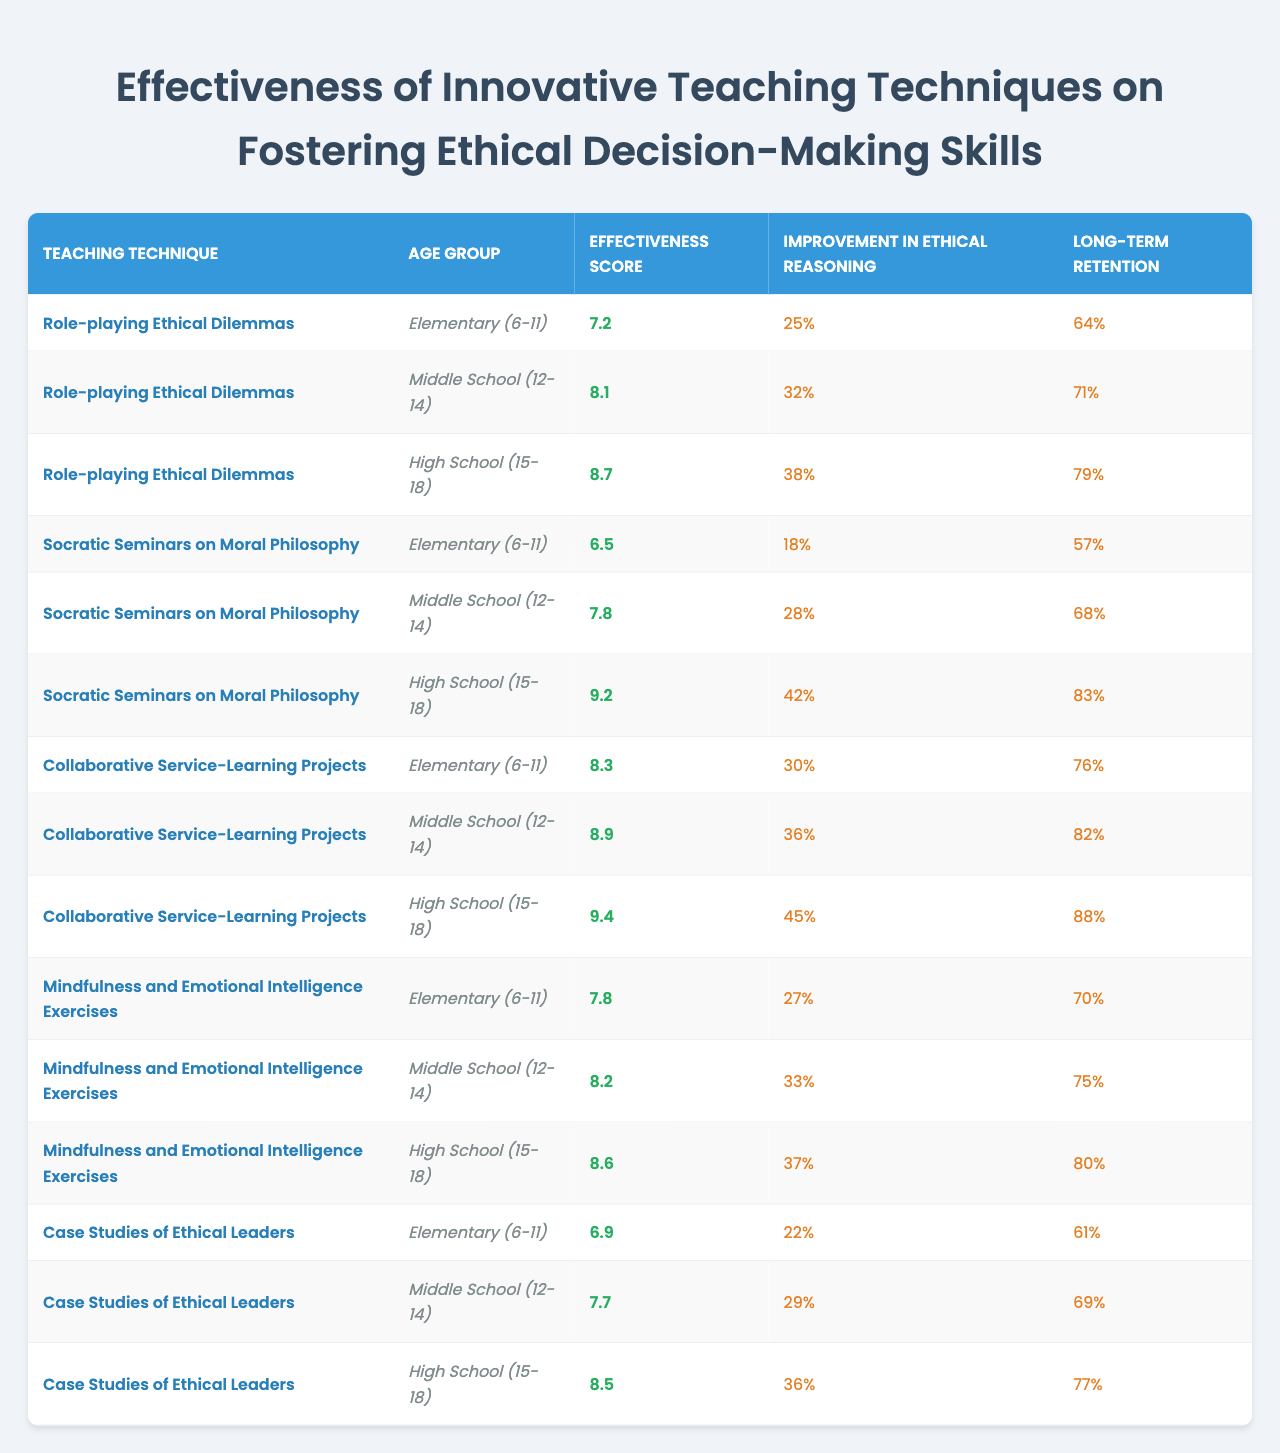What is the effectiveness score for Role-playing Ethical Dilemmas in High School? The table shows that the effectiveness score for the Role-playing Ethical Dilemmas technique in the High School age group is 8.7.
Answer: 8.7 Which technique has the highest effectiveness score for Middle School students? By comparing the effectiveness scores for Middle School students, Collaborative Service-Learning Projects has the highest score at 8.9.
Answer: Collaborative Service-Learning Projects What is the percentage improvement in ethical reasoning for the Elementary age group using Socratic Seminars on Moral Philosophy? The improvement in ethical reasoning for the Elementary age group using Socratic Seminars on Moral Philosophy is 18%, as stated in the table.
Answer: 18% How does the long-term retention of ethical decision-making skills compare between Role-playing Ethical Dilemmas and Mindfulness and Emotional Intelligence Exercises for High School students? The long-term retention for Role-playing Ethical Dilemmas is 79% and for Mindfulness and Emotional Intelligence Exercises it is 80%. Mindfulness and Emotional Intelligence Exercises has a slightly higher retention rate.
Answer: Mindfulness and Emotional Intelligence Exercises What is the average effectiveness score across all techniques for the Middle School age group? The effectiveness scores for Middle School students are 8.1 (Role-playing Ethical Dilemmas), 7.8 (Socratic Seminars), 8.9 (Collaborative Service-Learning), 8.2 (Mindfulness), and 7.7 (Case Studies). Thus, the average is (8.1 + 7.8 + 8.9 + 8.2 + 7.7) / 5 = 8.174.
Answer: 8.174 Is the improvement in ethical reasoning greater for High School students using Collaborative Service-Learning Projects or Role-playing Ethical Dilemmas? Collaborative Service-Learning Projects shows a 45% improvement, while Role-playing Ethical Dilemmas shows a 38% improvement. Therefore, the improvement is greater for Collaborative Service-Learning Projects.
Answer: Yes What percentage improvement does Mindfulness and Emotional Intelligence Exercises show for High School students compared to Elementary students? Mindfulness and Emotional Intelligence Exercises shows a 37% improvement for High School students and 27% for Elementary students. The difference is 37% - 27% = 10%, indicating a 10% greater improvement in High School students.
Answer: 10% Which technique shows the least long-term retention for the Elementary age group? Among the techniques listed for the Elementary age group, Socratic Seminars on Moral Philosophy shows the least long-term retention at 57%.
Answer: Socratic Seminars on Moral Philosophy What is the difference in long-term retention between Case Studies of Ethical Leaders in High School and Collaborative Service-Learning Projects in the same group? The long-term retention for Case Studies of Ethical Leaders in High School is 77%, and for Collaborative Service-Learning Projects, it is 88%. The difference is 88% - 77% = 11%.
Answer: 11% Which age group shows the highest overall improvement in ethical reasoning and what is the percentage? For High School students, the improvement in ethical reasoning is 45% from Collaborative Service-Learning Projects, which is the highest overall compared to other age groups and techniques.
Answer: High School, 45% 